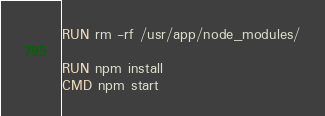Convert code to text. <code><loc_0><loc_0><loc_500><loc_500><_Dockerfile_>RUN rm -rf /usr/app/node_modules/

RUN npm install
CMD npm start</code> 